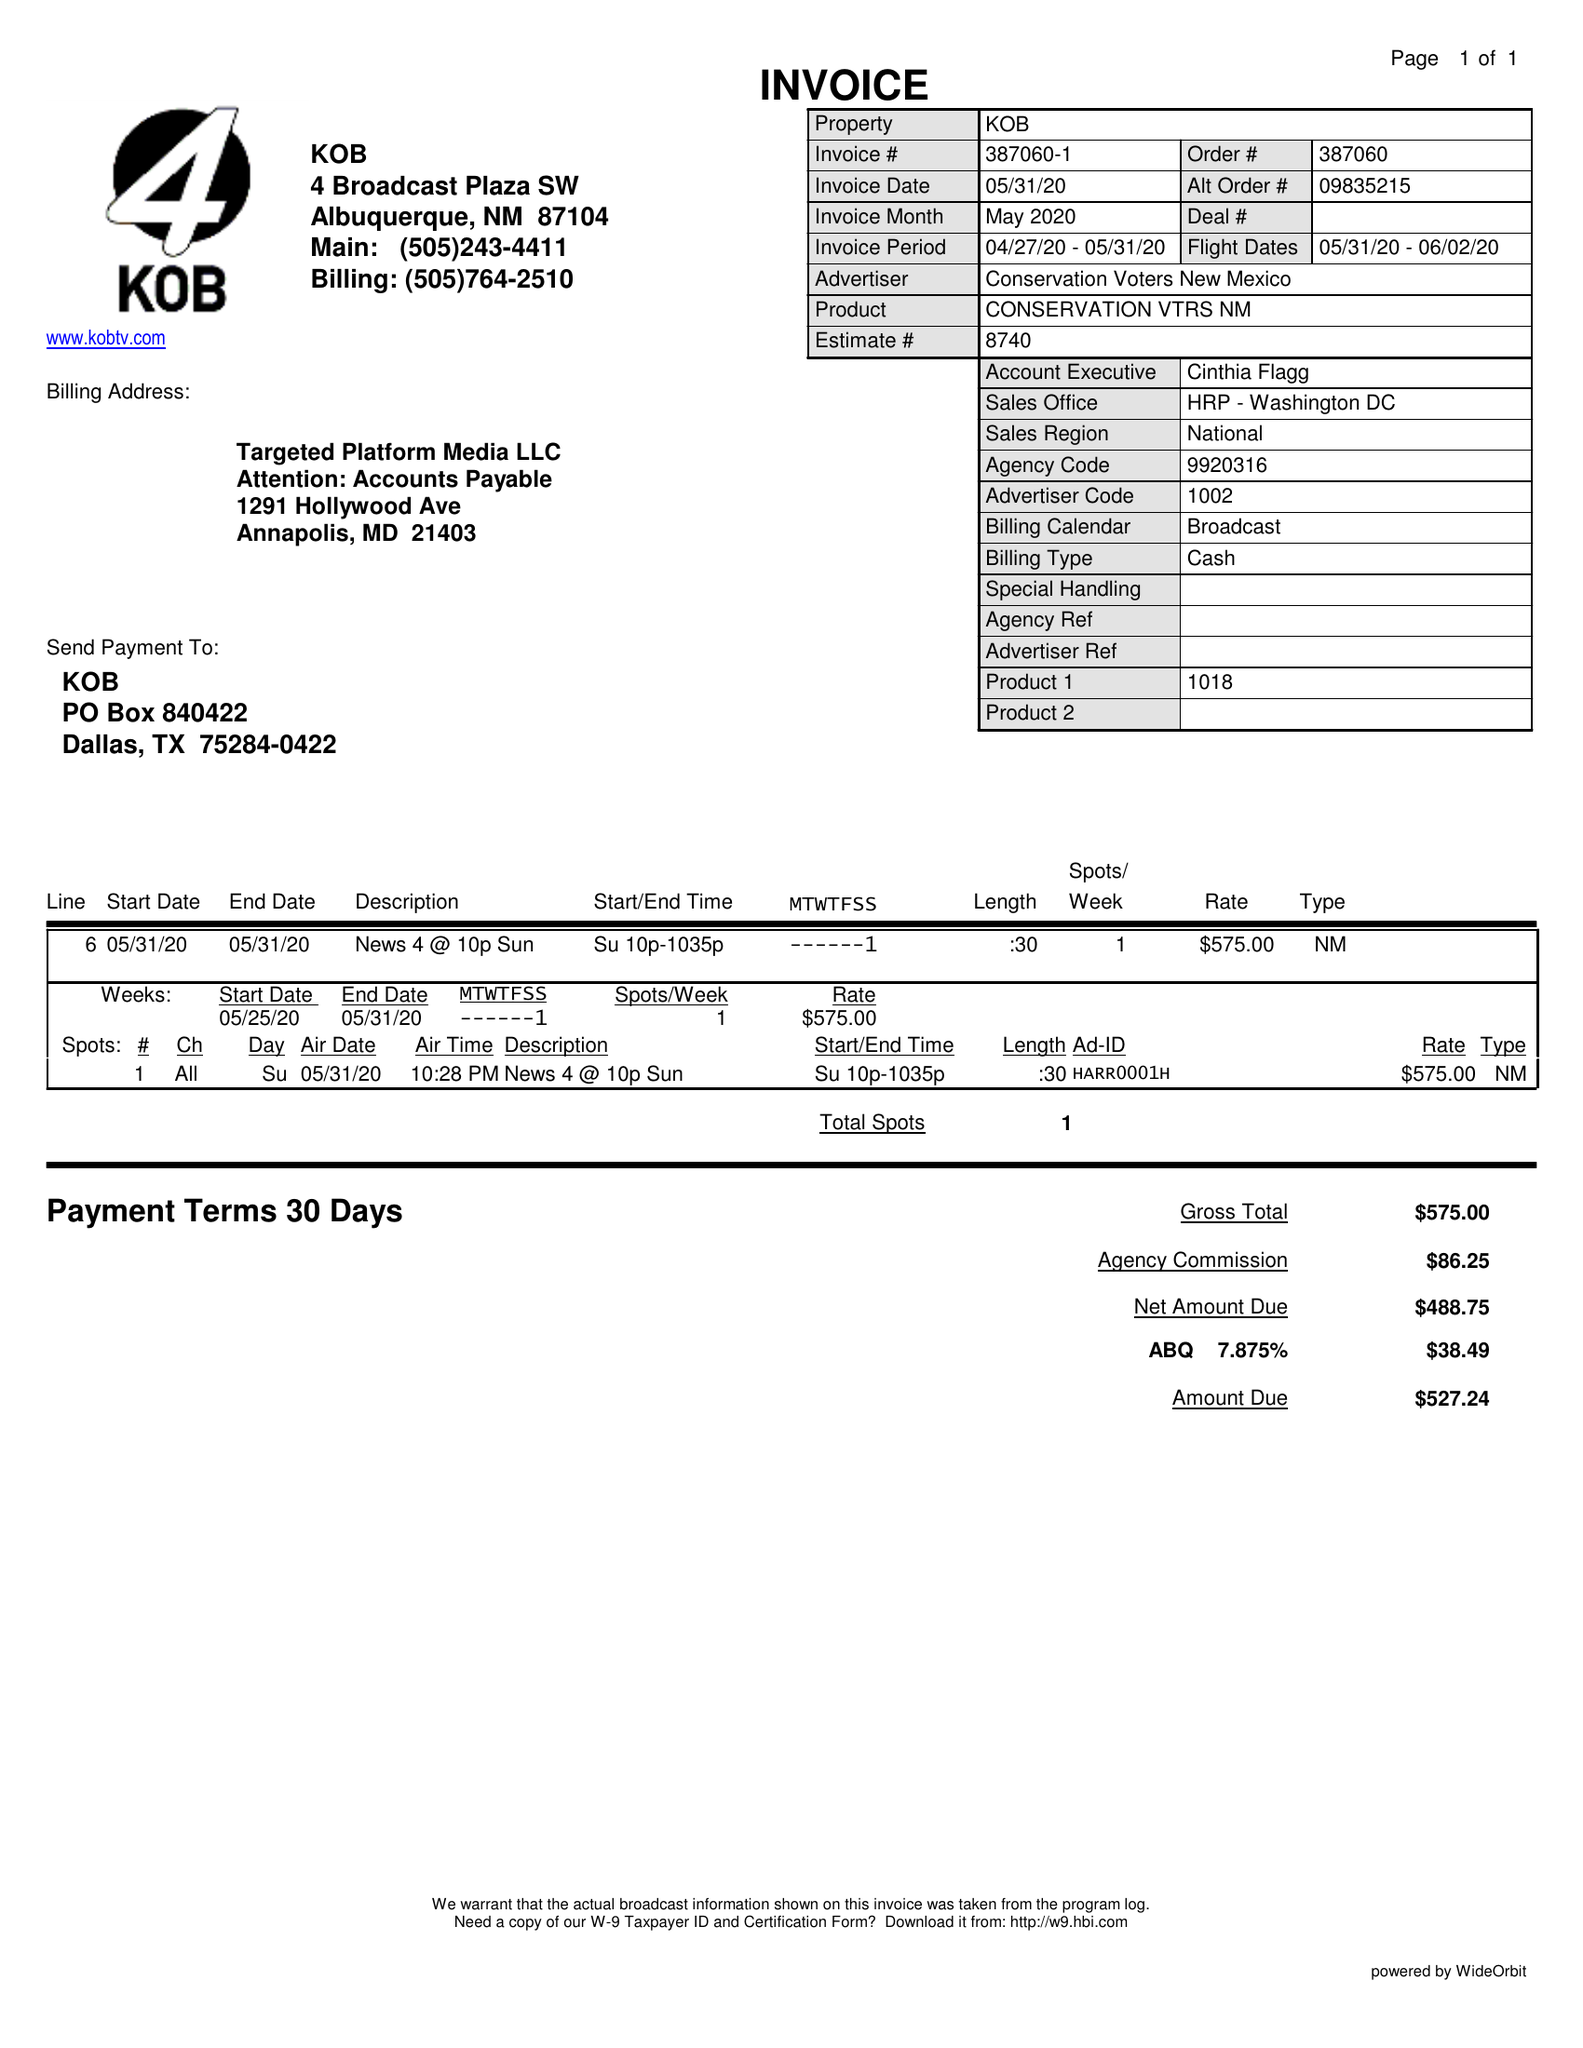What is the value for the flight_from?
Answer the question using a single word or phrase. 05/31/20 